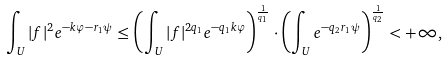Convert formula to latex. <formula><loc_0><loc_0><loc_500><loc_500>\int _ { U } | f | ^ { 2 } e ^ { - k \varphi - r _ { 1 } \psi } \leq \left ( \int _ { U } | f | ^ { 2 q _ { 1 } } e ^ { - q _ { 1 } k \varphi } \right ) ^ { \frac { 1 } { q _ { 1 } } } \cdot \left ( \int _ { U } e ^ { - q _ { 2 } r _ { 1 } \psi } \right ) ^ { \frac { 1 } { q _ { 2 } } } < + \infty ,</formula> 